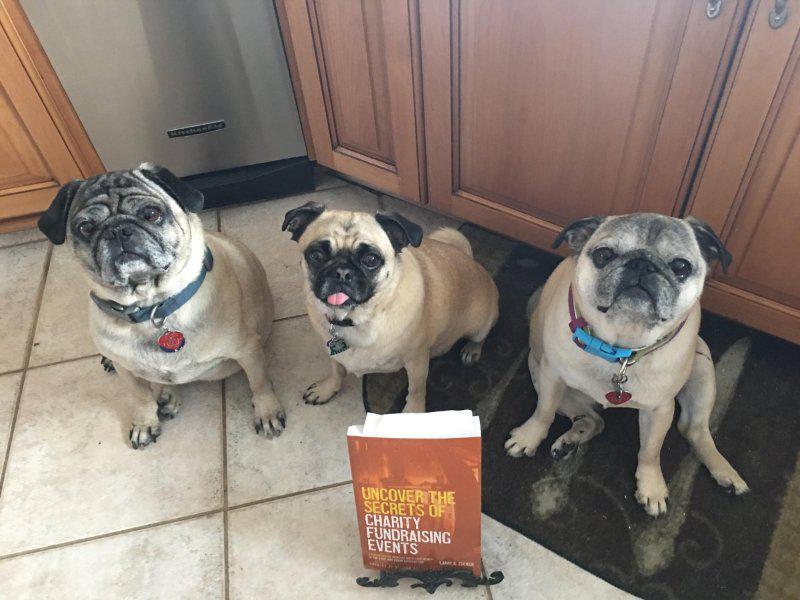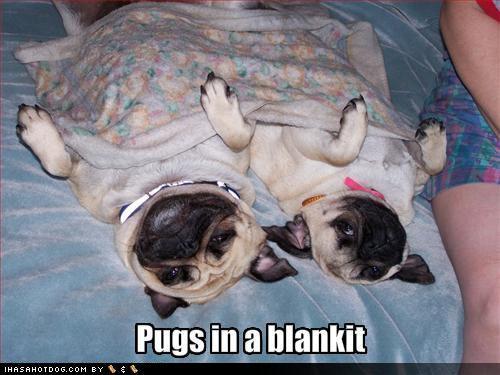The first image is the image on the left, the second image is the image on the right. Analyze the images presented: Is the assertion "All dogs shown are buff-beige pugs with darker muzzles, and one image contains three pugs sitting upright, while the other image contains at least two pugs on a type of bed." valid? Answer yes or no. Yes. The first image is the image on the left, the second image is the image on the right. Assess this claim about the two images: "In at least one image there are three pugs sharing one dog bed.". Correct or not? Answer yes or no. No. 